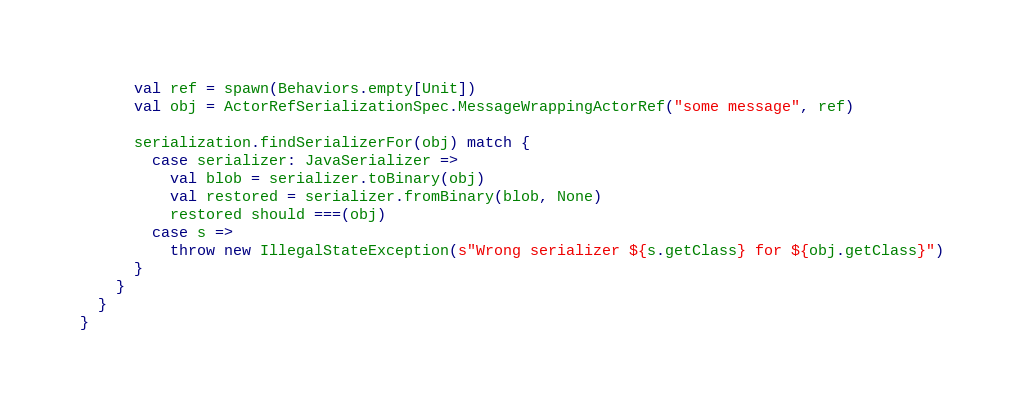Convert code to text. <code><loc_0><loc_0><loc_500><loc_500><_Scala_>      val ref = spawn(Behaviors.empty[Unit])
      val obj = ActorRefSerializationSpec.MessageWrappingActorRef("some message", ref)

      serialization.findSerializerFor(obj) match {
        case serializer: JavaSerializer =>
          val blob = serializer.toBinary(obj)
          val restored = serializer.fromBinary(blob, None)
          restored should ===(obj)
        case s =>
          throw new IllegalStateException(s"Wrong serializer ${s.getClass} for ${obj.getClass}")
      }
    }
  }
}
</code> 